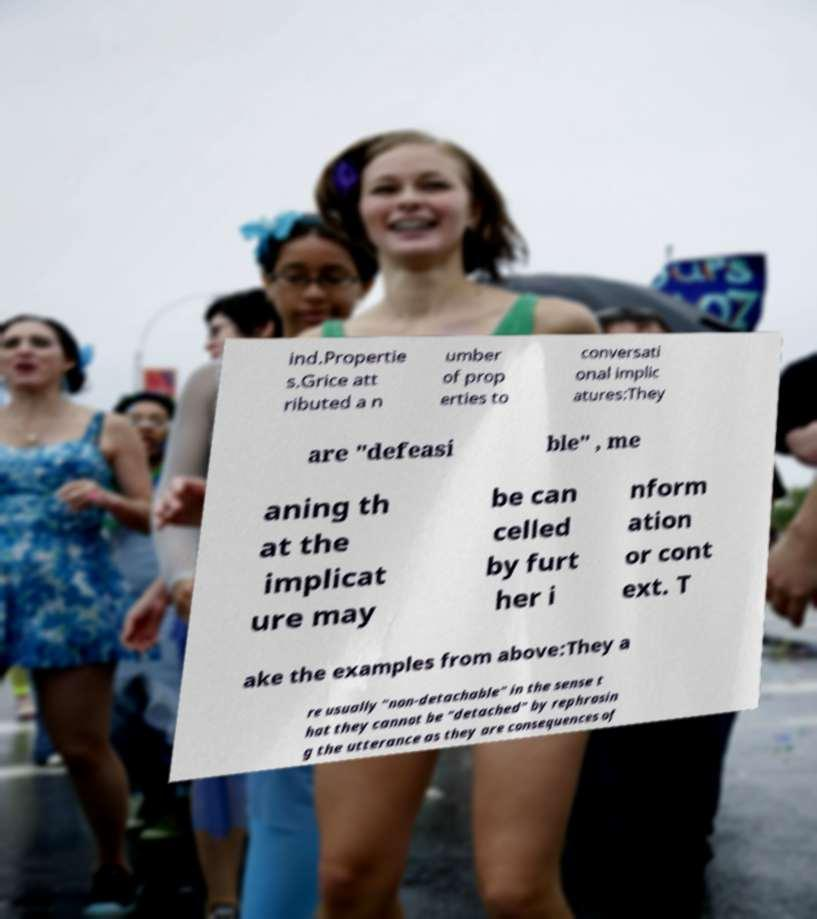Can you accurately transcribe the text from the provided image for me? ind.Propertie s.Grice att ributed a n umber of prop erties to conversati onal implic atures:They are "defeasi ble" , me aning th at the implicat ure may be can celled by furt her i nform ation or cont ext. T ake the examples from above:They a re usually "non-detachable" in the sense t hat they cannot be "detached" by rephrasin g the utterance as they are consequences of 